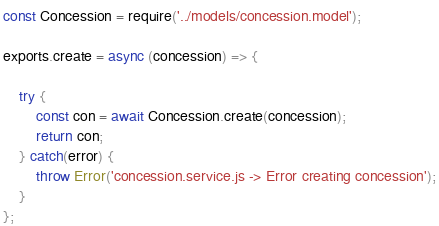<code> <loc_0><loc_0><loc_500><loc_500><_JavaScript_>const Concession = require('../models/concession.model');

exports.create = async (concession) => {

    try {
        const con = await Concession.create(concession);
        return con;
    } catch(error) {
        throw Error('concession.service.js -> Error creating concession');
    }
};</code> 